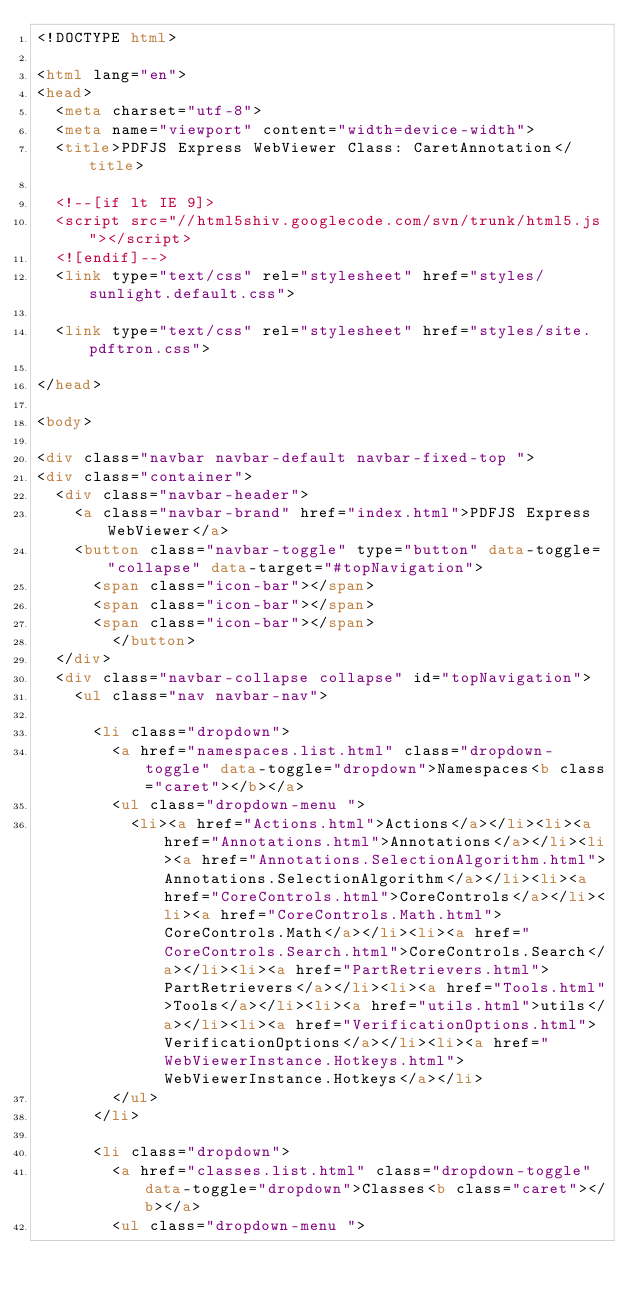Convert code to text. <code><loc_0><loc_0><loc_500><loc_500><_HTML_><!DOCTYPE html>

<html lang="en">
<head>
	<meta charset="utf-8">
	<meta name="viewport" content="width=device-width">
	<title>PDFJS Express WebViewer Class: CaretAnnotation</title>

	<!--[if lt IE 9]>
	<script src="//html5shiv.googlecode.com/svn/trunk/html5.js"></script>
	<![endif]-->
	<link type="text/css" rel="stylesheet" href="styles/sunlight.default.css">

	<link type="text/css" rel="stylesheet" href="styles/site.pdftron.css">
	
</head>

<body>

<div class="navbar navbar-default navbar-fixed-top ">
<div class="container">
	<div class="navbar-header">
		<a class="navbar-brand" href="index.html">PDFJS Express WebViewer</a>
		<button class="navbar-toggle" type="button" data-toggle="collapse" data-target="#topNavigation">
			<span class="icon-bar"></span>
			<span class="icon-bar"></span>
			<span class="icon-bar"></span>
        </button>
	</div>
	<div class="navbar-collapse collapse" id="topNavigation">
		<ul class="nav navbar-nav">
			
			<li class="dropdown">
				<a href="namespaces.list.html" class="dropdown-toggle" data-toggle="dropdown">Namespaces<b class="caret"></b></a>
				<ul class="dropdown-menu ">
					<li><a href="Actions.html">Actions</a></li><li><a href="Annotations.html">Annotations</a></li><li><a href="Annotations.SelectionAlgorithm.html">Annotations.SelectionAlgorithm</a></li><li><a href="CoreControls.html">CoreControls</a></li><li><a href="CoreControls.Math.html">CoreControls.Math</a></li><li><a href="CoreControls.Search.html">CoreControls.Search</a></li><li><a href="PartRetrievers.html">PartRetrievers</a></li><li><a href="Tools.html">Tools</a></li><li><a href="utils.html">utils</a></li><li><a href="VerificationOptions.html">VerificationOptions</a></li><li><a href="WebViewerInstance.Hotkeys.html">WebViewerInstance.Hotkeys</a></li>
				</ul>
			</li>
			
			<li class="dropdown">
				<a href="classes.list.html" class="dropdown-toggle" data-toggle="dropdown">Classes<b class="caret"></b></a>
				<ul class="dropdown-menu "></code> 